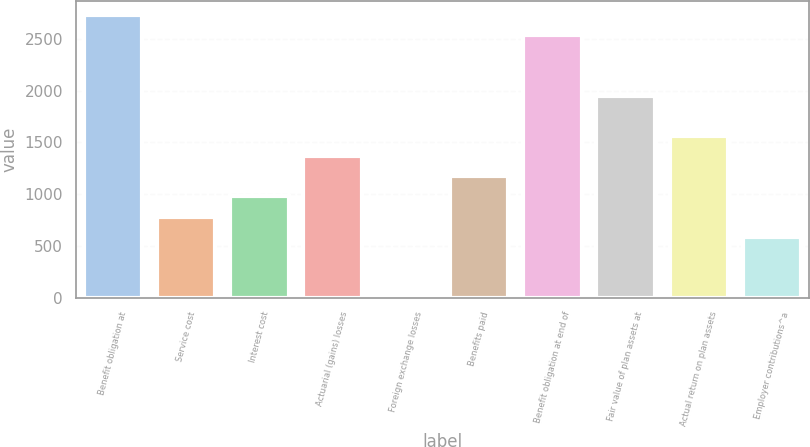<chart> <loc_0><loc_0><loc_500><loc_500><bar_chart><fcel>Benefit obligation at<fcel>Service cost<fcel>Interest cost<fcel>Actuarial (gains) losses<fcel>Foreign exchange losses<fcel>Benefits paid<fcel>Benefit obligation at end of<fcel>Fair value of plan assets at<fcel>Actual return on plan assets<fcel>Employer contributions^a<nl><fcel>2735.2<fcel>782.2<fcel>977.5<fcel>1368.1<fcel>1<fcel>1172.8<fcel>2539.9<fcel>1954<fcel>1563.4<fcel>586.9<nl></chart> 